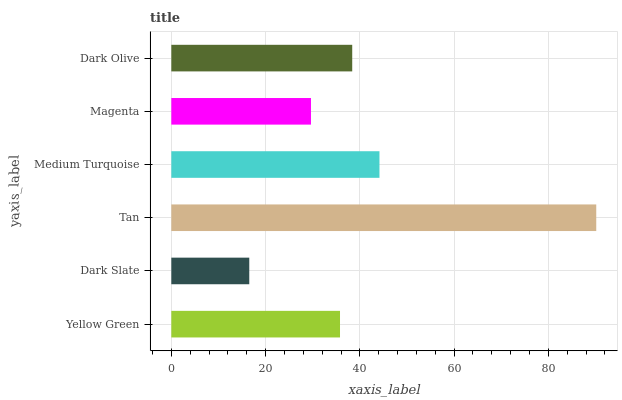Is Dark Slate the minimum?
Answer yes or no. Yes. Is Tan the maximum?
Answer yes or no. Yes. Is Tan the minimum?
Answer yes or no. No. Is Dark Slate the maximum?
Answer yes or no. No. Is Tan greater than Dark Slate?
Answer yes or no. Yes. Is Dark Slate less than Tan?
Answer yes or no. Yes. Is Dark Slate greater than Tan?
Answer yes or no. No. Is Tan less than Dark Slate?
Answer yes or no. No. Is Dark Olive the high median?
Answer yes or no. Yes. Is Yellow Green the low median?
Answer yes or no. Yes. Is Medium Turquoise the high median?
Answer yes or no. No. Is Magenta the low median?
Answer yes or no. No. 